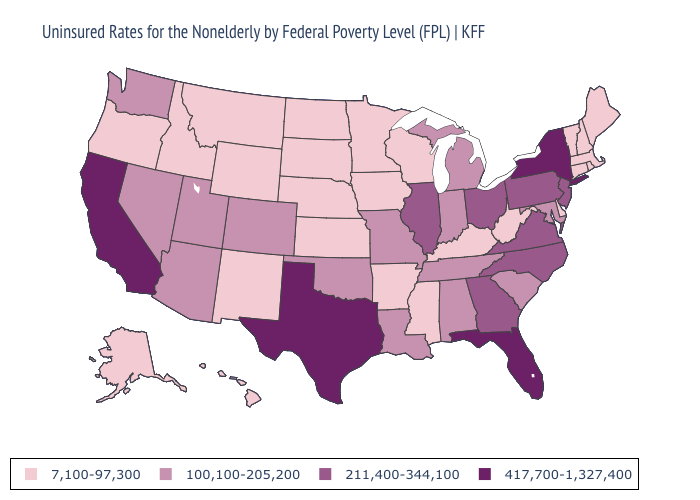Does Wisconsin have the lowest value in the USA?
Short answer required. Yes. Among the states that border Colorado , which have the lowest value?
Keep it brief. Kansas, Nebraska, New Mexico, Wyoming. Does the first symbol in the legend represent the smallest category?
Quick response, please. Yes. What is the highest value in the MidWest ?
Short answer required. 211,400-344,100. Name the states that have a value in the range 211,400-344,100?
Keep it brief. Georgia, Illinois, New Jersey, North Carolina, Ohio, Pennsylvania, Virginia. Name the states that have a value in the range 417,700-1,327,400?
Concise answer only. California, Florida, New York, Texas. Name the states that have a value in the range 417,700-1,327,400?
Answer briefly. California, Florida, New York, Texas. Among the states that border Colorado , which have the lowest value?
Short answer required. Kansas, Nebraska, New Mexico, Wyoming. Name the states that have a value in the range 417,700-1,327,400?
Give a very brief answer. California, Florida, New York, Texas. Does New York have the lowest value in the USA?
Be succinct. No. What is the value of Illinois?
Concise answer only. 211,400-344,100. Does the first symbol in the legend represent the smallest category?
Quick response, please. Yes. What is the lowest value in the Northeast?
Give a very brief answer. 7,100-97,300. What is the value of Tennessee?
Short answer required. 100,100-205,200. Does Michigan have the lowest value in the MidWest?
Short answer required. No. 